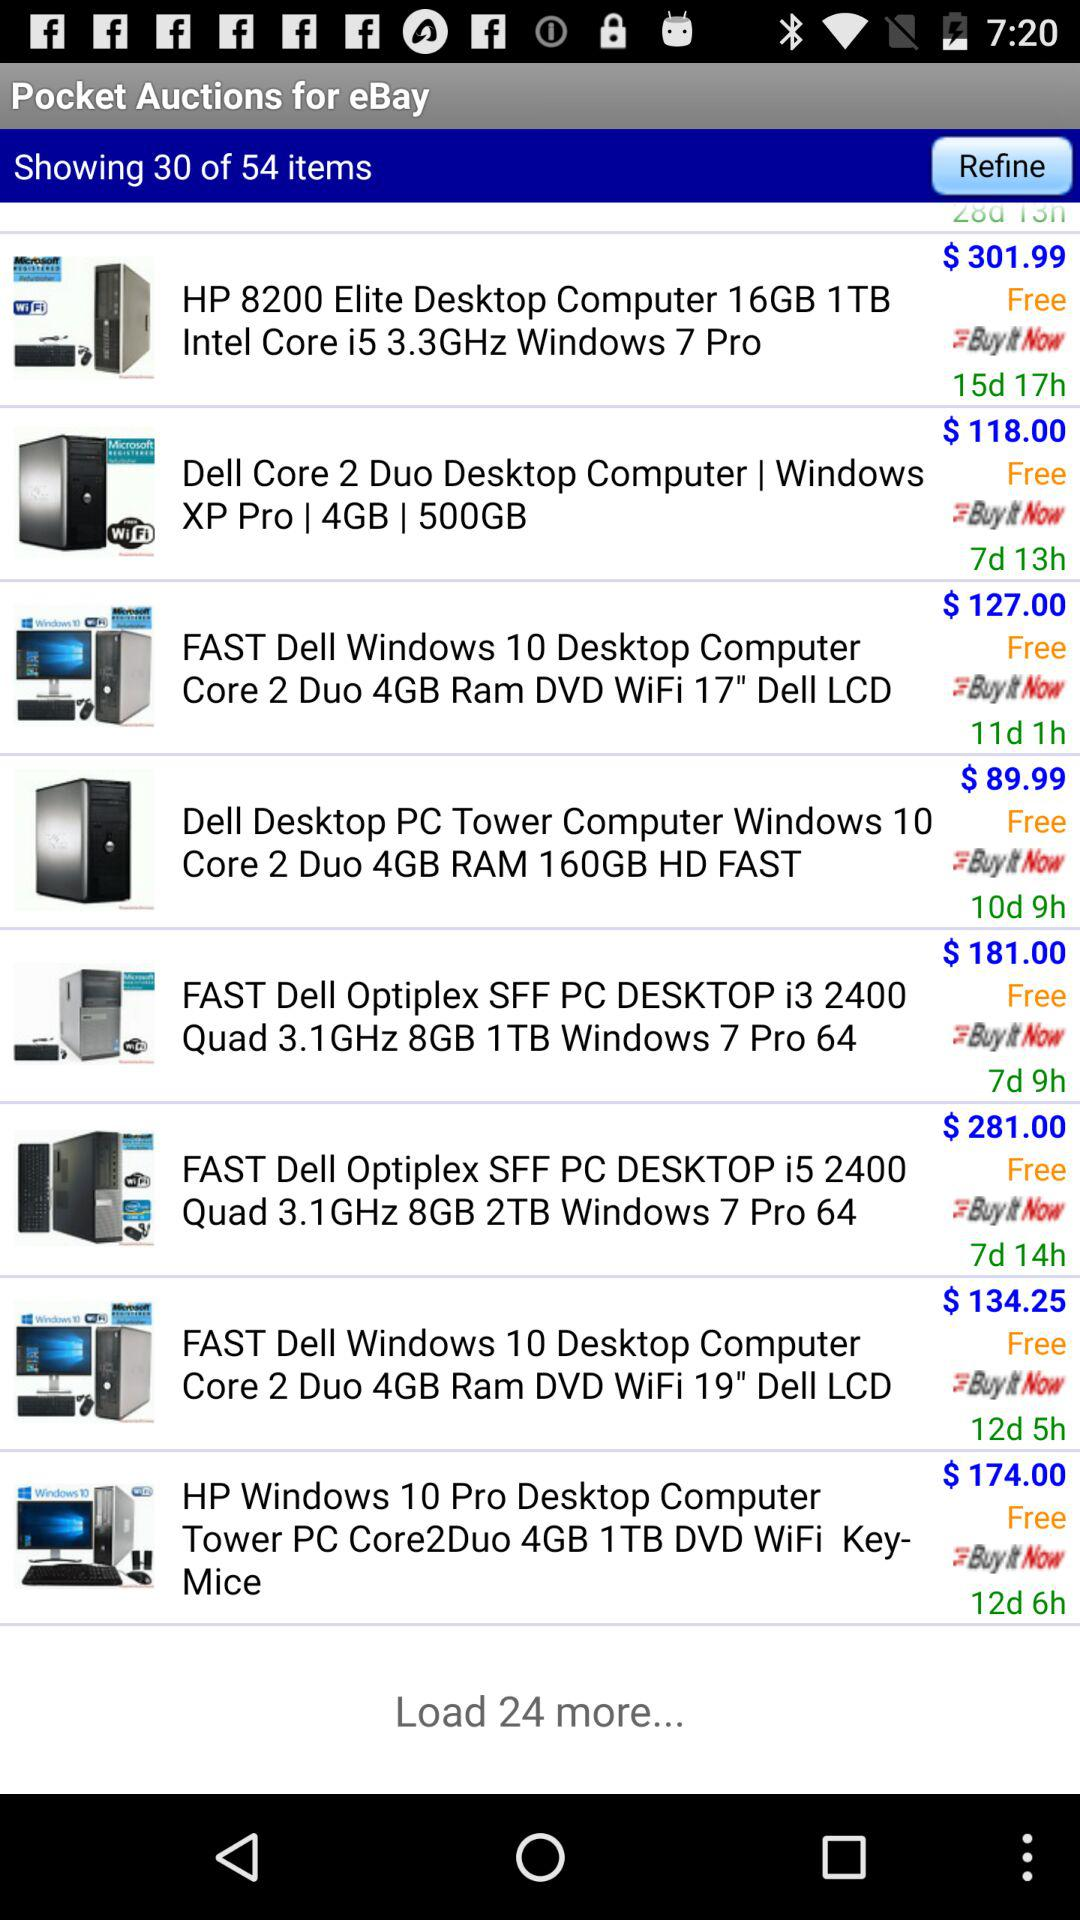How many dollars is the cheapest item?
Answer the question using a single word or phrase. $89.99 